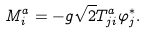Convert formula to latex. <formula><loc_0><loc_0><loc_500><loc_500>M ^ { a } _ { i } = - g { \sqrt { 2 } } T ^ { a } _ { j i } \varphi ^ { * } _ { j } .</formula> 